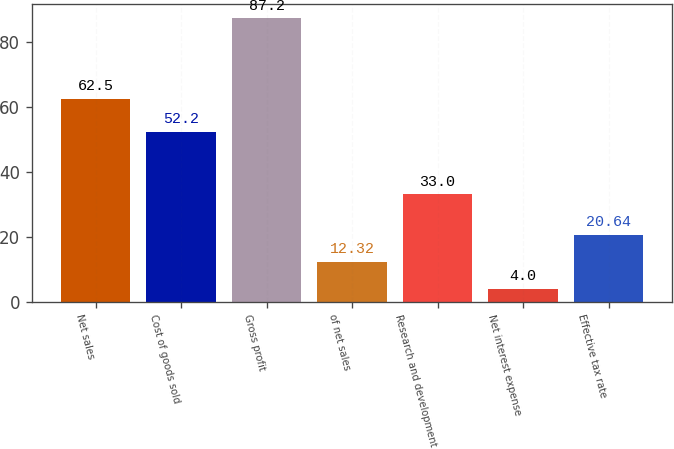<chart> <loc_0><loc_0><loc_500><loc_500><bar_chart><fcel>Net sales<fcel>Cost of goods sold<fcel>Gross profit<fcel>of net sales<fcel>Research and development<fcel>Net interest expense<fcel>Effective tax rate<nl><fcel>62.5<fcel>52.2<fcel>87.2<fcel>12.32<fcel>33<fcel>4<fcel>20.64<nl></chart> 